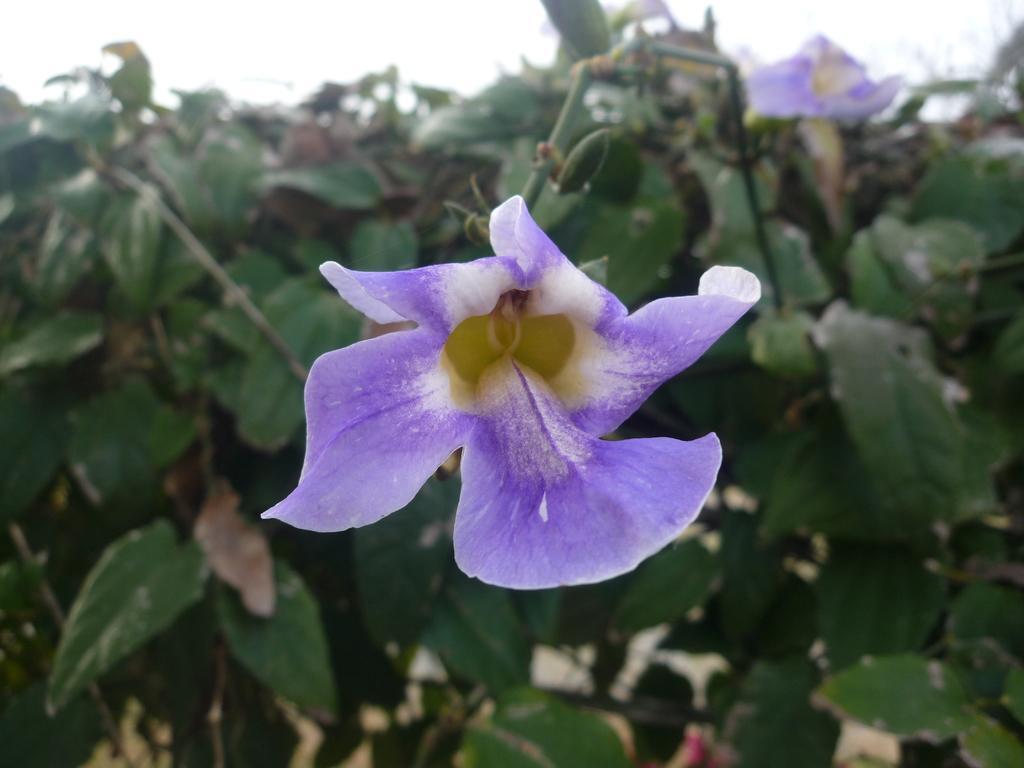How would you summarize this image in a sentence or two? In this picture there is a flower which is in violet and white color and there are few green leaves behind it. 